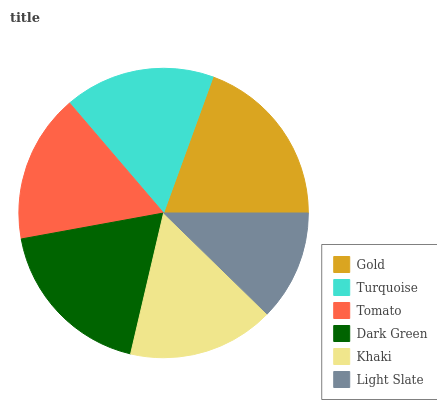Is Light Slate the minimum?
Answer yes or no. Yes. Is Gold the maximum?
Answer yes or no. Yes. Is Turquoise the minimum?
Answer yes or no. No. Is Turquoise the maximum?
Answer yes or no. No. Is Gold greater than Turquoise?
Answer yes or no. Yes. Is Turquoise less than Gold?
Answer yes or no. Yes. Is Turquoise greater than Gold?
Answer yes or no. No. Is Gold less than Turquoise?
Answer yes or no. No. Is Turquoise the high median?
Answer yes or no. Yes. Is Tomato the low median?
Answer yes or no. Yes. Is Dark Green the high median?
Answer yes or no. No. Is Gold the low median?
Answer yes or no. No. 